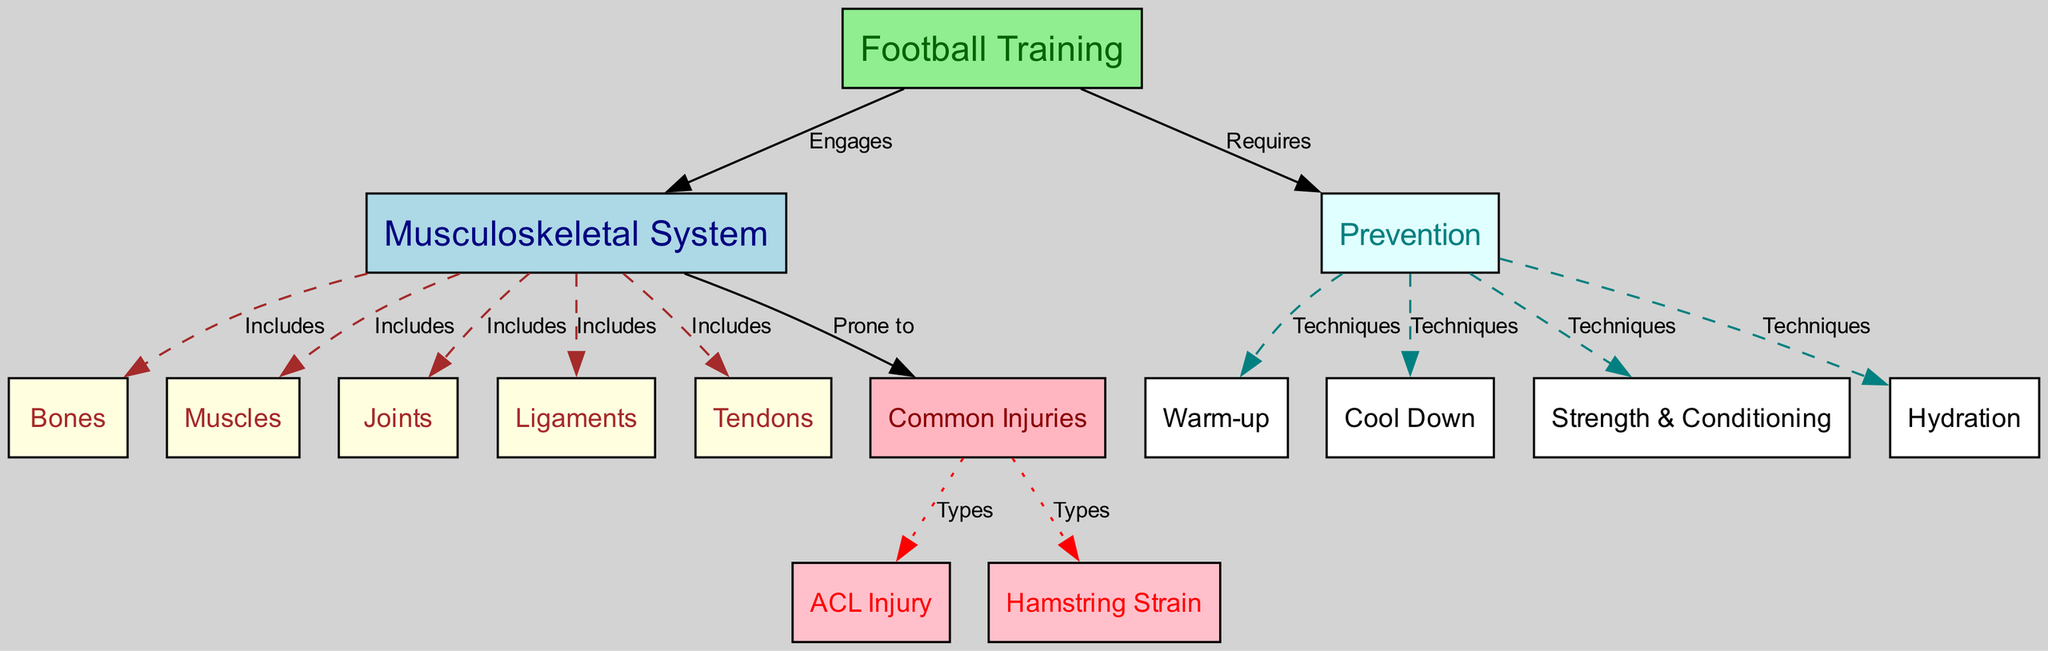What does the musculoskeletal system include? The diagram specifies that the "Musculoskeletal System" includes several components: "Bones," "Muscles," "Joints," "Ligaments," and "Tendons." This includes five distinct components.
Answer: Bones, Muscles, Joints, Ligaments, Tendons How many common injuries are listed in the diagram? The diagram shows two types of common injuries associated with the musculoskeletal system: "ACL Injury" and "Hamstring Strain." Thus, there are two listed common injuries.
Answer: Two What type of injury is related to ligaments? There is a direct line from "Common Injuries" to "Anterior Cruciate Ligament Injury," indicating this injury is specifically related to ligaments.
Answer: ACL Injury Which techniques are categorized under prevention? The diagram indicates four techniques under "Prevention," namely "Warm-up," "Cool Down," "Strength & Conditioning," and "Hydration." By counting, we find four techniques involved in injury prevention.
Answer: Warm-up, Cool Down, Strength & Conditioning, Hydration What is required by football training for injury prevention? The diagram clearly shows that "Football Training" requires "Prevention." Thus, prevention is a key component within the football training process.
Answer: Prevention Which node connects to tendons? A direct edge leads from "Musculoskeletal System" to "Tendons," defining the relationship that tendons are an included component of the musculoskeletal system.
Answer: Tendons What type of injury is most common in football training? The diagram indicates that "Common Injuries" are prone to specific types, including "ACL Injury" and "Hamstring Strain," but the overall title implies that both are common in the context of football training.
Answer: ACL Injury, Hamstring Strain What does a warm-up help to prevent? The diagram connects "Warm-up" under "Prevention," showing it is part of techniques that help prevent injuries during activities like football training. Therefore, a warm-up aids in injury prevention.
Answer: Injury Prevention What role do muscles play in football training? The diagram shows that "Football Training" engages the "Musculoskeletal System," which specifically includes "Muscles." Thus, muscles have an active role during football training.
Answer: Engaged in Football Training 